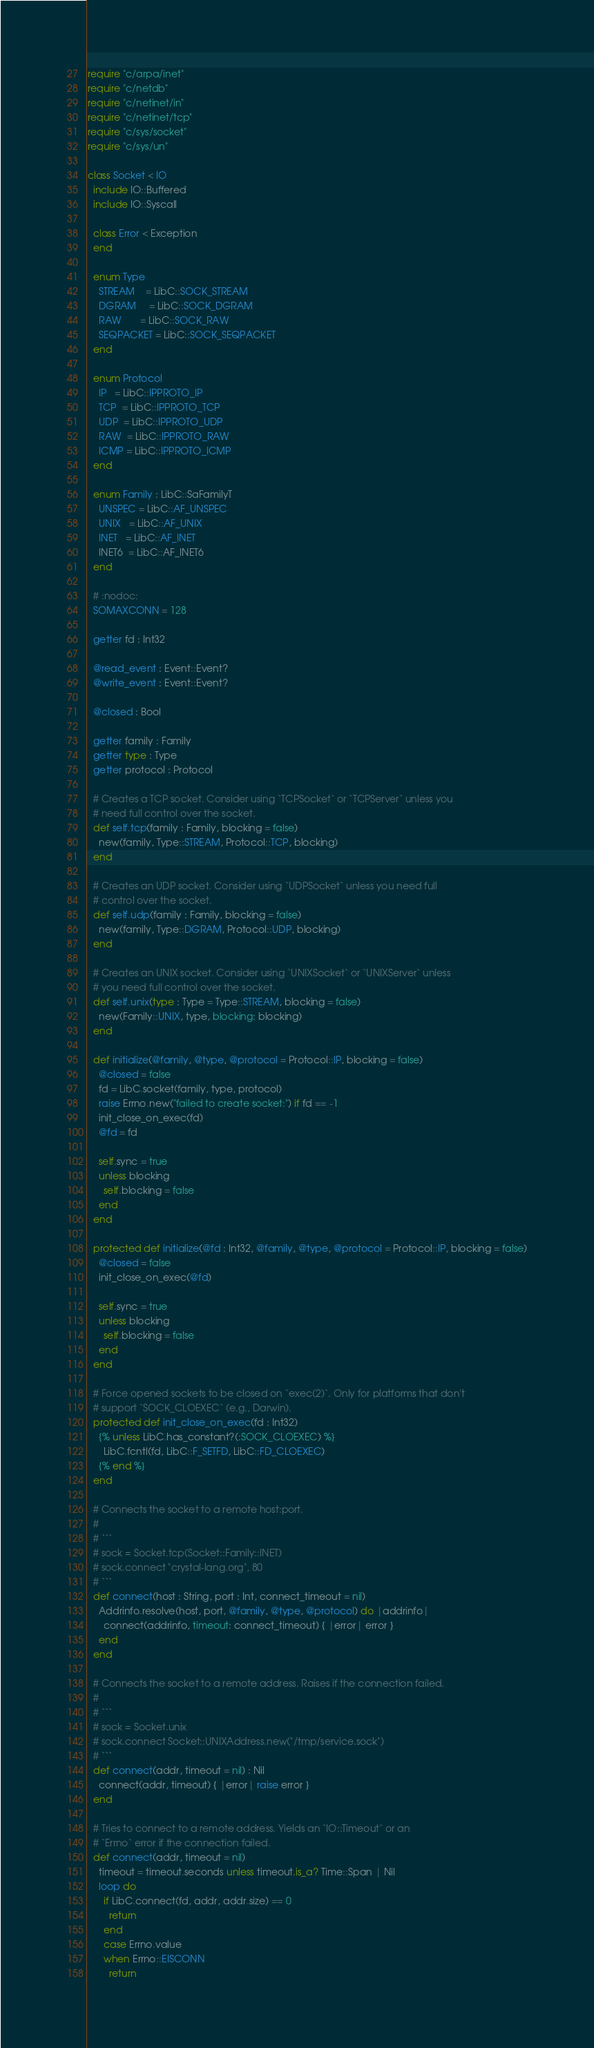<code> <loc_0><loc_0><loc_500><loc_500><_Crystal_>require "c/arpa/inet"
require "c/netdb"
require "c/netinet/in"
require "c/netinet/tcp"
require "c/sys/socket"
require "c/sys/un"

class Socket < IO
  include IO::Buffered
  include IO::Syscall

  class Error < Exception
  end

  enum Type
    STREAM    = LibC::SOCK_STREAM
    DGRAM     = LibC::SOCK_DGRAM
    RAW       = LibC::SOCK_RAW
    SEQPACKET = LibC::SOCK_SEQPACKET
  end

  enum Protocol
    IP   = LibC::IPPROTO_IP
    TCP  = LibC::IPPROTO_TCP
    UDP  = LibC::IPPROTO_UDP
    RAW  = LibC::IPPROTO_RAW
    ICMP = LibC::IPPROTO_ICMP
  end

  enum Family : LibC::SaFamilyT
    UNSPEC = LibC::AF_UNSPEC
    UNIX   = LibC::AF_UNIX
    INET   = LibC::AF_INET
    INET6  = LibC::AF_INET6
  end

  # :nodoc:
  SOMAXCONN = 128

  getter fd : Int32

  @read_event : Event::Event?
  @write_event : Event::Event?

  @closed : Bool

  getter family : Family
  getter type : Type
  getter protocol : Protocol

  # Creates a TCP socket. Consider using `TCPSocket` or `TCPServer` unless you
  # need full control over the socket.
  def self.tcp(family : Family, blocking = false)
    new(family, Type::STREAM, Protocol::TCP, blocking)
  end

  # Creates an UDP socket. Consider using `UDPSocket` unless you need full
  # control over the socket.
  def self.udp(family : Family, blocking = false)
    new(family, Type::DGRAM, Protocol::UDP, blocking)
  end

  # Creates an UNIX socket. Consider using `UNIXSocket` or `UNIXServer` unless
  # you need full control over the socket.
  def self.unix(type : Type = Type::STREAM, blocking = false)
    new(Family::UNIX, type, blocking: blocking)
  end

  def initialize(@family, @type, @protocol = Protocol::IP, blocking = false)
    @closed = false
    fd = LibC.socket(family, type, protocol)
    raise Errno.new("failed to create socket:") if fd == -1
    init_close_on_exec(fd)
    @fd = fd

    self.sync = true
    unless blocking
      self.blocking = false
    end
  end

  protected def initialize(@fd : Int32, @family, @type, @protocol = Protocol::IP, blocking = false)
    @closed = false
    init_close_on_exec(@fd)

    self.sync = true
    unless blocking
      self.blocking = false
    end
  end

  # Force opened sockets to be closed on `exec(2)`. Only for platforms that don't
  # support `SOCK_CLOEXEC` (e.g., Darwin).
  protected def init_close_on_exec(fd : Int32)
    {% unless LibC.has_constant?(:SOCK_CLOEXEC) %}
      LibC.fcntl(fd, LibC::F_SETFD, LibC::FD_CLOEXEC)
    {% end %}
  end

  # Connects the socket to a remote host:port.
  #
  # ```
  # sock = Socket.tcp(Socket::Family::INET)
  # sock.connect "crystal-lang.org", 80
  # ```
  def connect(host : String, port : Int, connect_timeout = nil)
    Addrinfo.resolve(host, port, @family, @type, @protocol) do |addrinfo|
      connect(addrinfo, timeout: connect_timeout) { |error| error }
    end
  end

  # Connects the socket to a remote address. Raises if the connection failed.
  #
  # ```
  # sock = Socket.unix
  # sock.connect Socket::UNIXAddress.new("/tmp/service.sock")
  # ```
  def connect(addr, timeout = nil) : Nil
    connect(addr, timeout) { |error| raise error }
  end

  # Tries to connect to a remote address. Yields an `IO::Timeout` or an
  # `Errno` error if the connection failed.
  def connect(addr, timeout = nil)
    timeout = timeout.seconds unless timeout.is_a? Time::Span | Nil
    loop do
      if LibC.connect(fd, addr, addr.size) == 0
        return
      end
      case Errno.value
      when Errno::EISCONN
        return</code> 